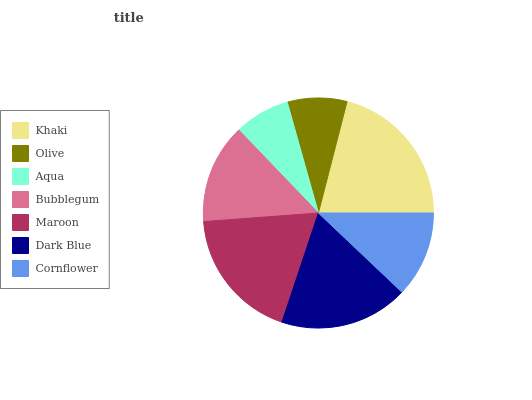Is Aqua the minimum?
Answer yes or no. Yes. Is Khaki the maximum?
Answer yes or no. Yes. Is Olive the minimum?
Answer yes or no. No. Is Olive the maximum?
Answer yes or no. No. Is Khaki greater than Olive?
Answer yes or no. Yes. Is Olive less than Khaki?
Answer yes or no. Yes. Is Olive greater than Khaki?
Answer yes or no. No. Is Khaki less than Olive?
Answer yes or no. No. Is Bubblegum the high median?
Answer yes or no. Yes. Is Bubblegum the low median?
Answer yes or no. Yes. Is Maroon the high median?
Answer yes or no. No. Is Cornflower the low median?
Answer yes or no. No. 